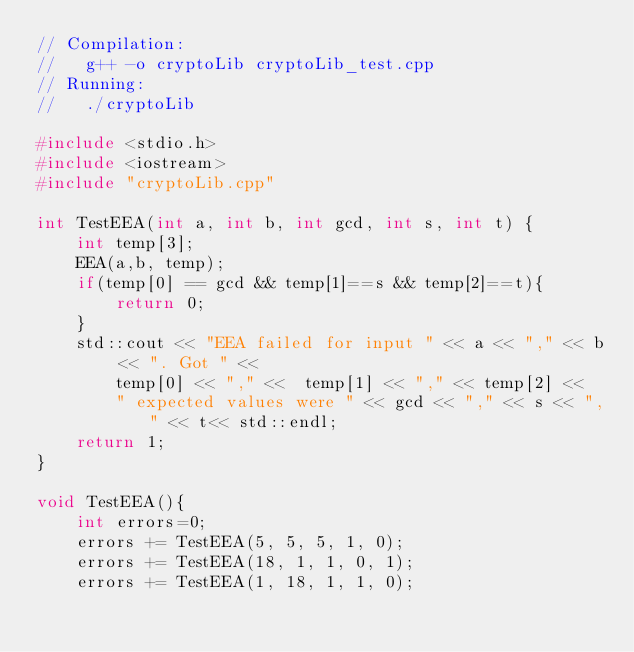<code> <loc_0><loc_0><loc_500><loc_500><_C++_>// Compilation:
//   g++ -o cryptoLib cryptoLib_test.cpp
// Running:
//   ./cryptoLib

#include <stdio.h>
#include <iostream>
#include "cryptoLib.cpp"

int TestEEA(int a, int b, int gcd, int s, int t) {
    int temp[3];
    EEA(a,b, temp);
    if(temp[0] == gcd && temp[1]==s && temp[2]==t){
        return 0;
    }
    std::cout << "EEA failed for input " << a << "," << b << ". Got " <<
        temp[0] << "," <<  temp[1] << "," << temp[2] <<
        " expected values were " << gcd << "," << s << "," << t<< std::endl;
    return 1;
}

void TestEEA(){
    int errors=0;
    errors += TestEEA(5, 5, 5, 1, 0);
    errors += TestEEA(18, 1, 1, 0, 1);
    errors += TestEEA(1, 18, 1, 1, 0);</code> 